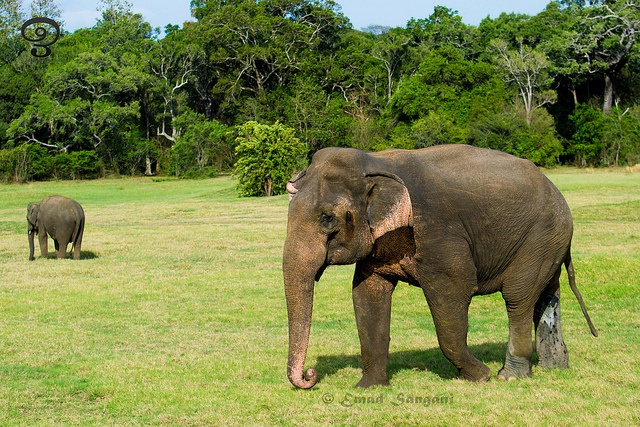Describe the objects in this image and their specific colors. I can see elephant in darkgreen, olive, black, and gray tones and elephant in darkgreen, gray, olive, and black tones in this image. 